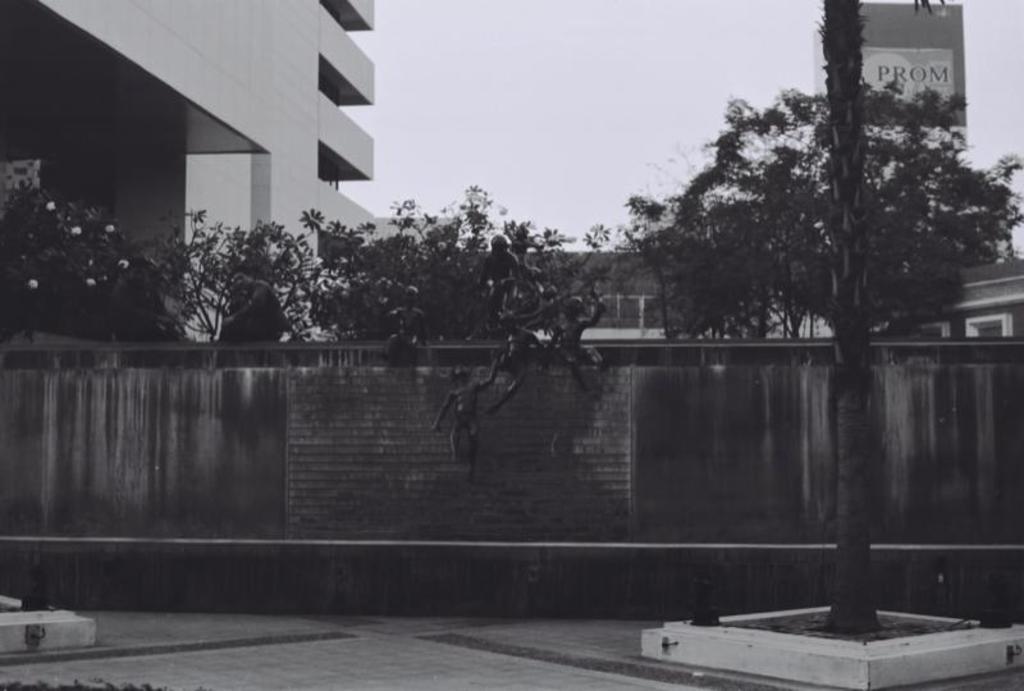Can you describe this image briefly? In this image, we can see a wall, there are some trees, at the left side there is a building, at the top there is a sky. 